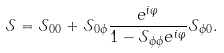Convert formula to latex. <formula><loc_0><loc_0><loc_500><loc_500>\mathcal { S } = \mathcal { S } _ { 0 0 } + \mathcal { S } _ { 0 \phi } \frac { e ^ { i \varphi } } { 1 - \mathcal { S } _ { \phi \phi } e ^ { i \varphi } } \mathcal { S } _ { \phi 0 } .</formula> 